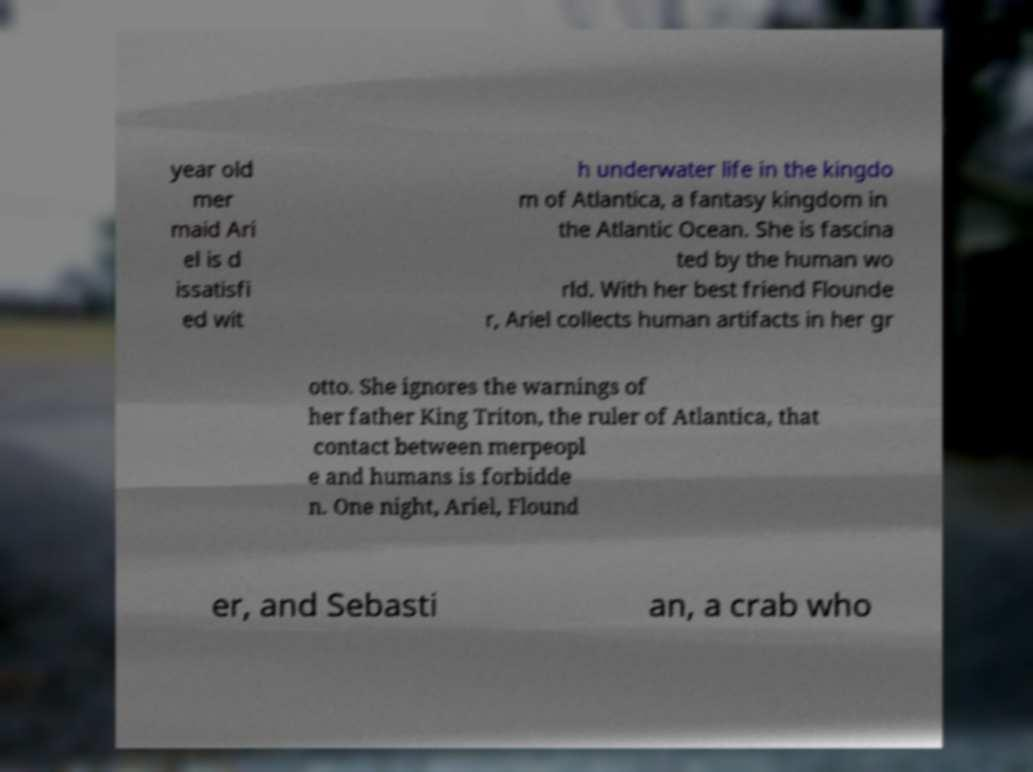Please read and relay the text visible in this image. What does it say? year old mer maid Ari el is d issatisfi ed wit h underwater life in the kingdo m of Atlantica, a fantasy kingdom in the Atlantic Ocean. She is fascina ted by the human wo rld. With her best friend Flounde r, Ariel collects human artifacts in her gr otto. She ignores the warnings of her father King Triton, the ruler of Atlantica, that contact between merpeopl e and humans is forbidde n. One night, Ariel, Flound er, and Sebasti an, a crab who 